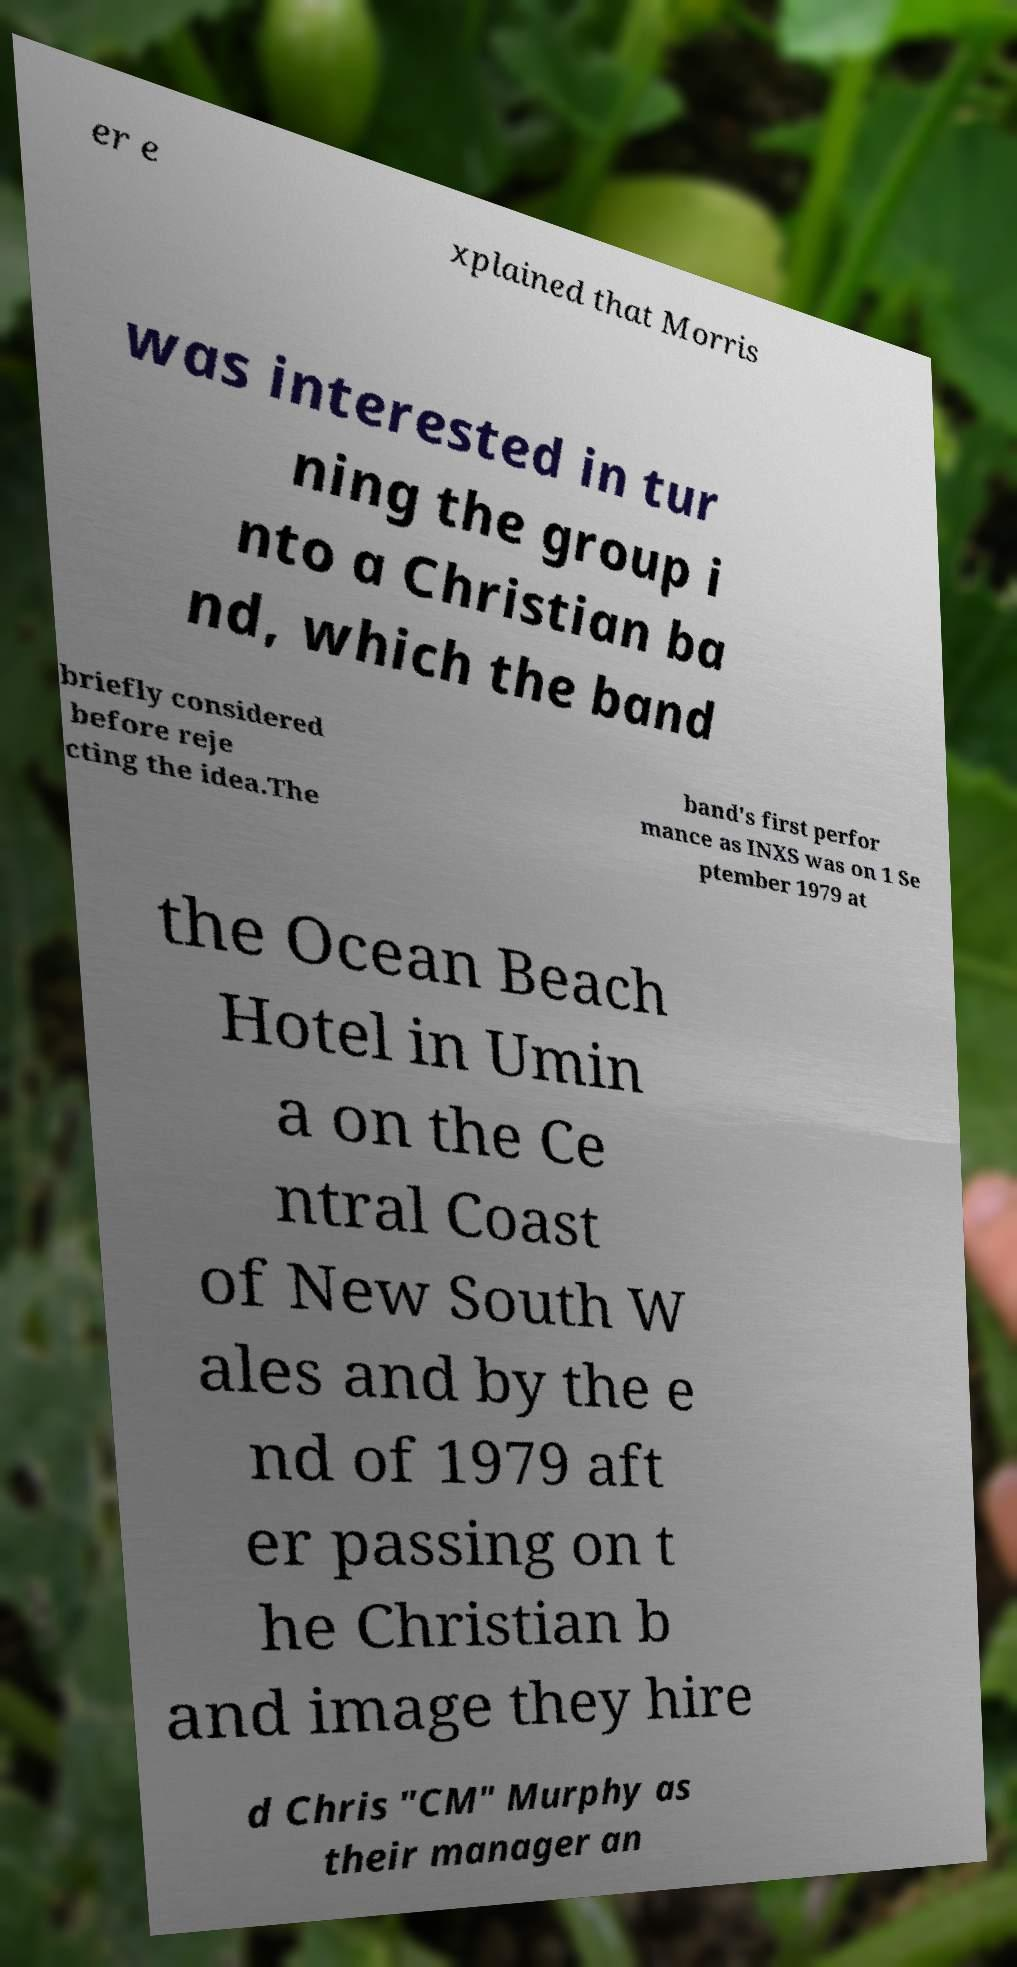Please identify and transcribe the text found in this image. er e xplained that Morris was interested in tur ning the group i nto a Christian ba nd, which the band briefly considered before reje cting the idea.The band's first perfor mance as INXS was on 1 Se ptember 1979 at the Ocean Beach Hotel in Umin a on the Ce ntral Coast of New South W ales and by the e nd of 1979 aft er passing on t he Christian b and image they hire d Chris "CM" Murphy as their manager an 